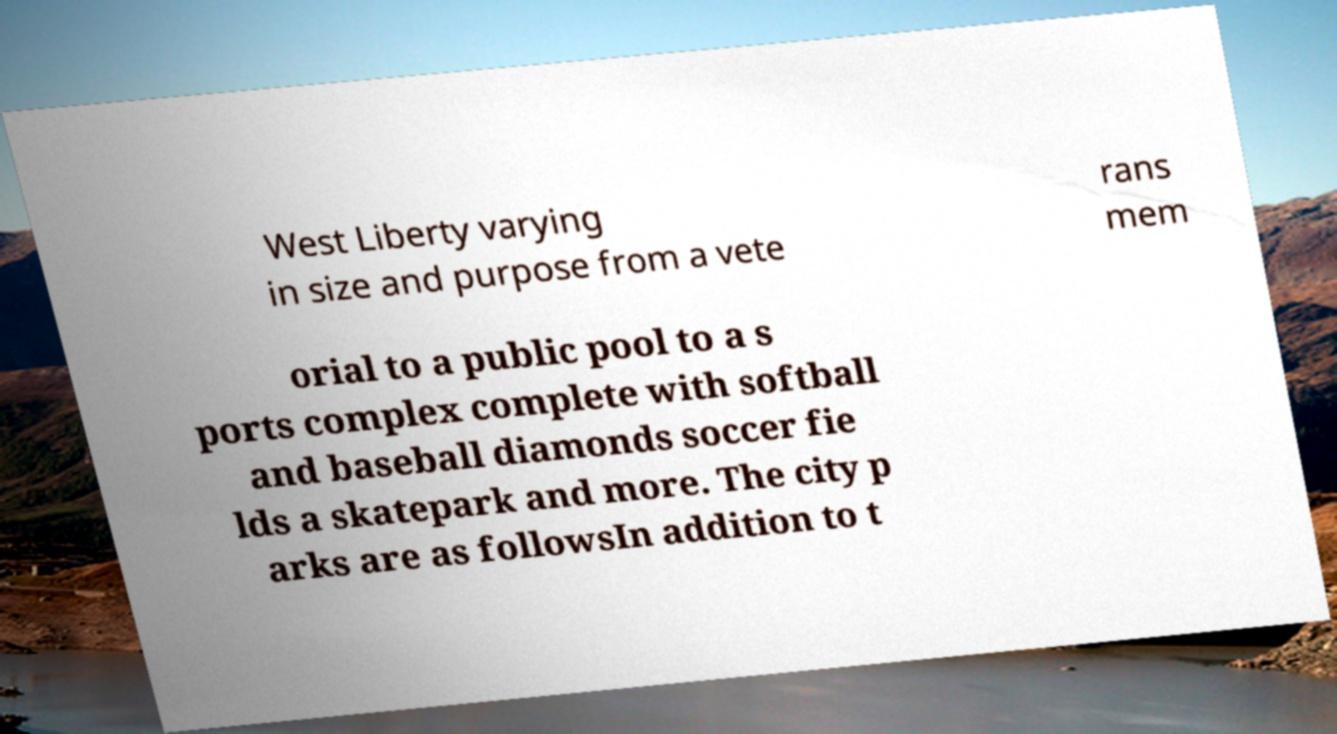Could you extract and type out the text from this image? West Liberty varying in size and purpose from a vete rans mem orial to a public pool to a s ports complex complete with softball and baseball diamonds soccer fie lds a skatepark and more. The city p arks are as followsIn addition to t 